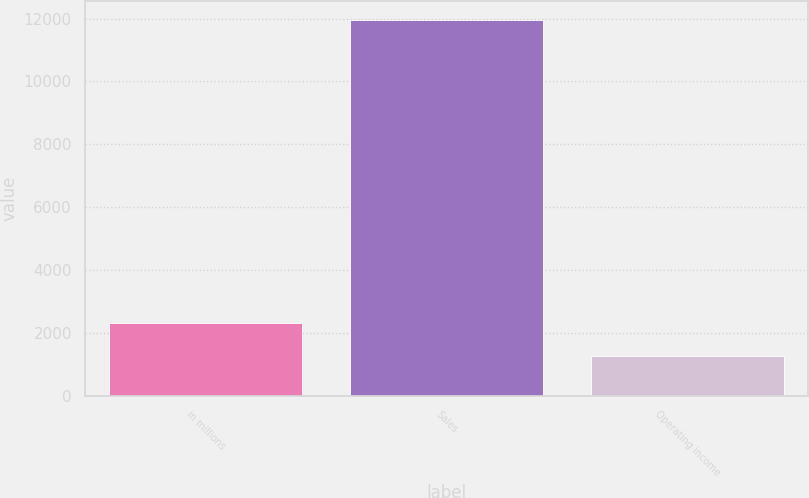Convert chart to OTSL. <chart><loc_0><loc_0><loc_500><loc_500><bar_chart><fcel>in millions<fcel>Sales<fcel>Operating income<nl><fcel>2328.6<fcel>11955<fcel>1259<nl></chart> 